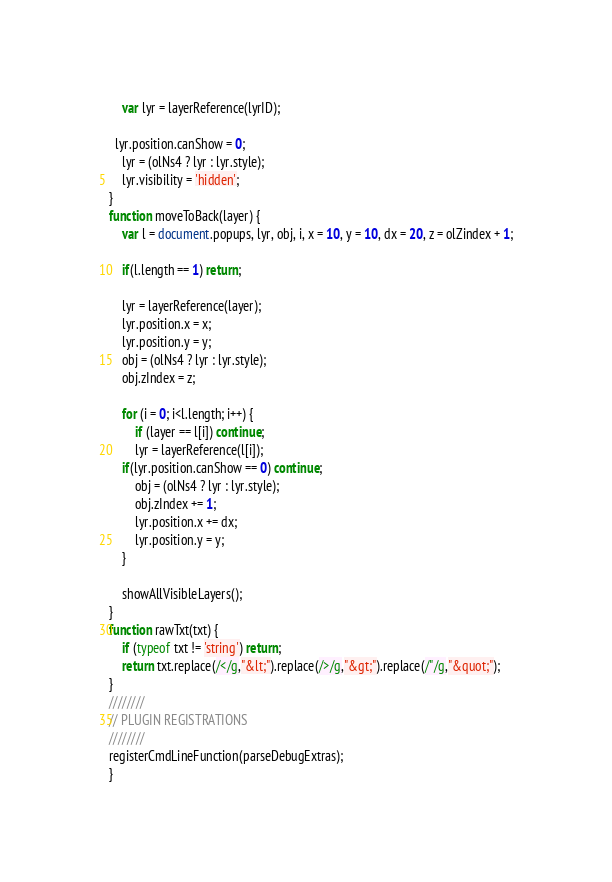Convert code to text. <code><loc_0><loc_0><loc_500><loc_500><_JavaScript_>	var lyr = layerReference(lyrID);

  lyr.position.canShow = 0;
	lyr = (olNs4 ? lyr : lyr.style);
	lyr.visibility = 'hidden';
}
function moveToBack(layer) {
	var l = document.popups, lyr, obj, i, x = 10, y = 10, dx = 20, z = olZindex + 1;

	if(l.length == 1) return;

	lyr = layerReference(layer);
	lyr.position.x = x;
	lyr.position.y = y;
	obj = (olNs4 ? lyr : lyr.style);
	obj.zIndex = z;

	for (i = 0; i<l.length; i++) {
		if (layer == l[i]) continue;
		lyr = layerReference(l[i]);
    if(lyr.position.canShow == 0) continue;
		obj = (olNs4 ? lyr : lyr.style);
		obj.zIndex += 1;
		lyr.position.x += dx;
		lyr.position.y = y;
	}

	showAllVisibleLayers();
}
function rawTxt(txt) {
	if (typeof txt != 'string') return;
	return txt.replace(/</g,"&lt;").replace(/>/g,"&gt;").replace(/"/g,"&quot;");
}
////////
// PLUGIN REGISTRATIONS
////////
registerCmdLineFunction(parseDebugExtras);
}</code> 